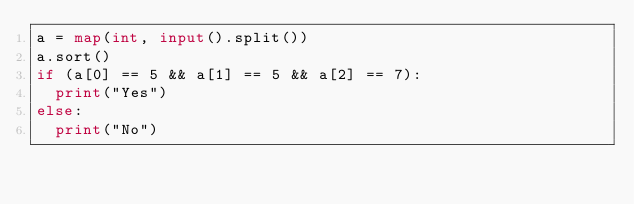<code> <loc_0><loc_0><loc_500><loc_500><_Python_>a = map(int, input().split())
a.sort()
if (a[0] == 5 && a[1] == 5 && a[2] == 7):
  print("Yes")
else:
  print("No")
  </code> 